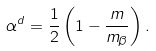<formula> <loc_0><loc_0><loc_500><loc_500>\alpha ^ { d } = \frac { 1 } { 2 } \left ( 1 - \frac { m } { m _ { \beta } } \right ) .</formula> 